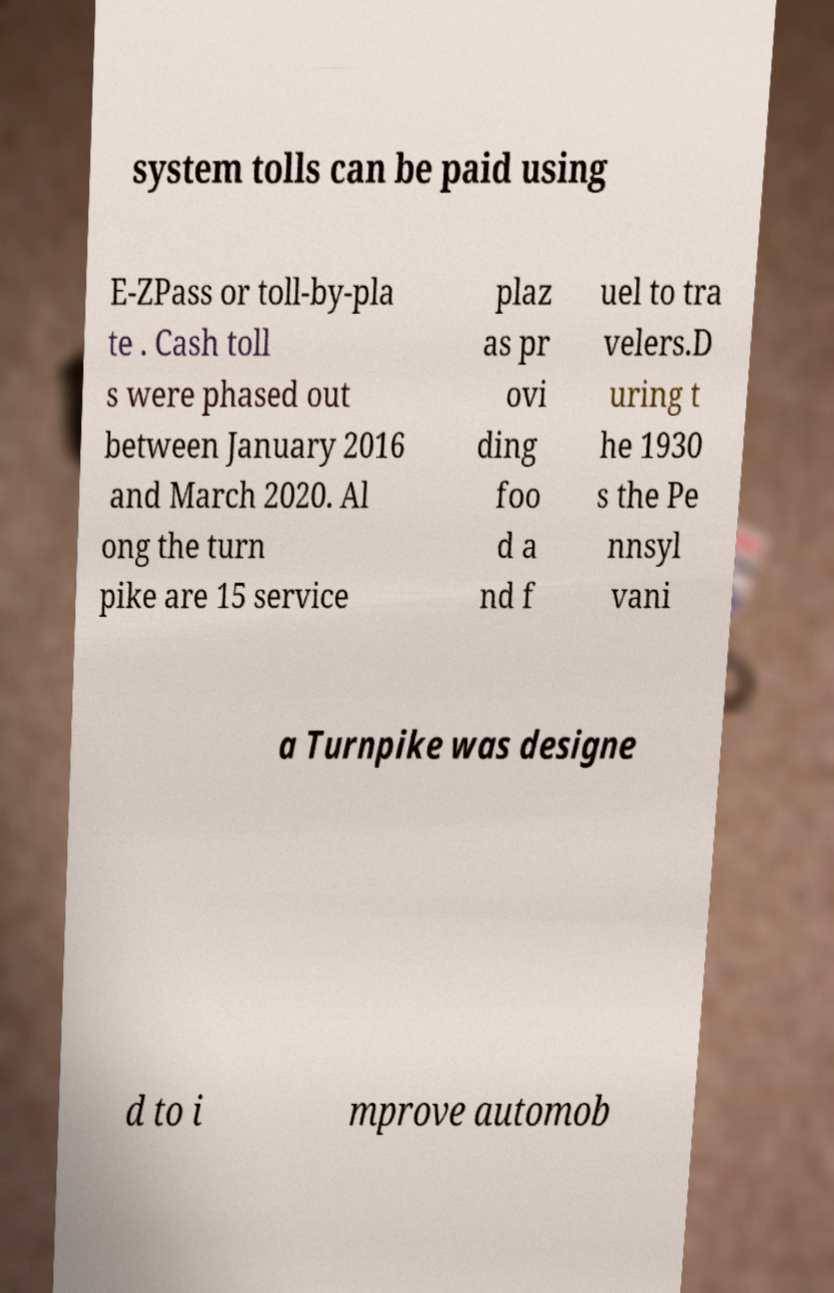Please read and relay the text visible in this image. What does it say? system tolls can be paid using E-ZPass or toll-by-pla te . Cash toll s were phased out between January 2016 and March 2020. Al ong the turn pike are 15 service plaz as pr ovi ding foo d a nd f uel to tra velers.D uring t he 1930 s the Pe nnsyl vani a Turnpike was designe d to i mprove automob 